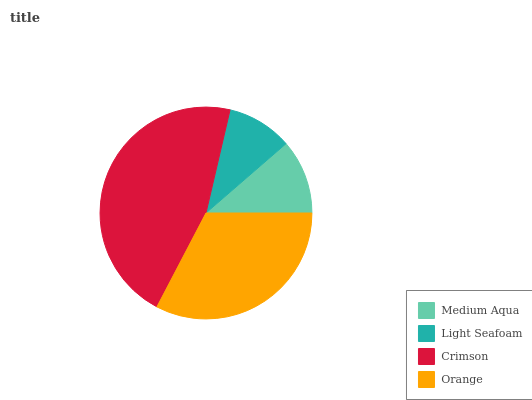Is Light Seafoam the minimum?
Answer yes or no. Yes. Is Crimson the maximum?
Answer yes or no. Yes. Is Crimson the minimum?
Answer yes or no. No. Is Light Seafoam the maximum?
Answer yes or no. No. Is Crimson greater than Light Seafoam?
Answer yes or no. Yes. Is Light Seafoam less than Crimson?
Answer yes or no. Yes. Is Light Seafoam greater than Crimson?
Answer yes or no. No. Is Crimson less than Light Seafoam?
Answer yes or no. No. Is Orange the high median?
Answer yes or no. Yes. Is Medium Aqua the low median?
Answer yes or no. Yes. Is Medium Aqua the high median?
Answer yes or no. No. Is Crimson the low median?
Answer yes or no. No. 